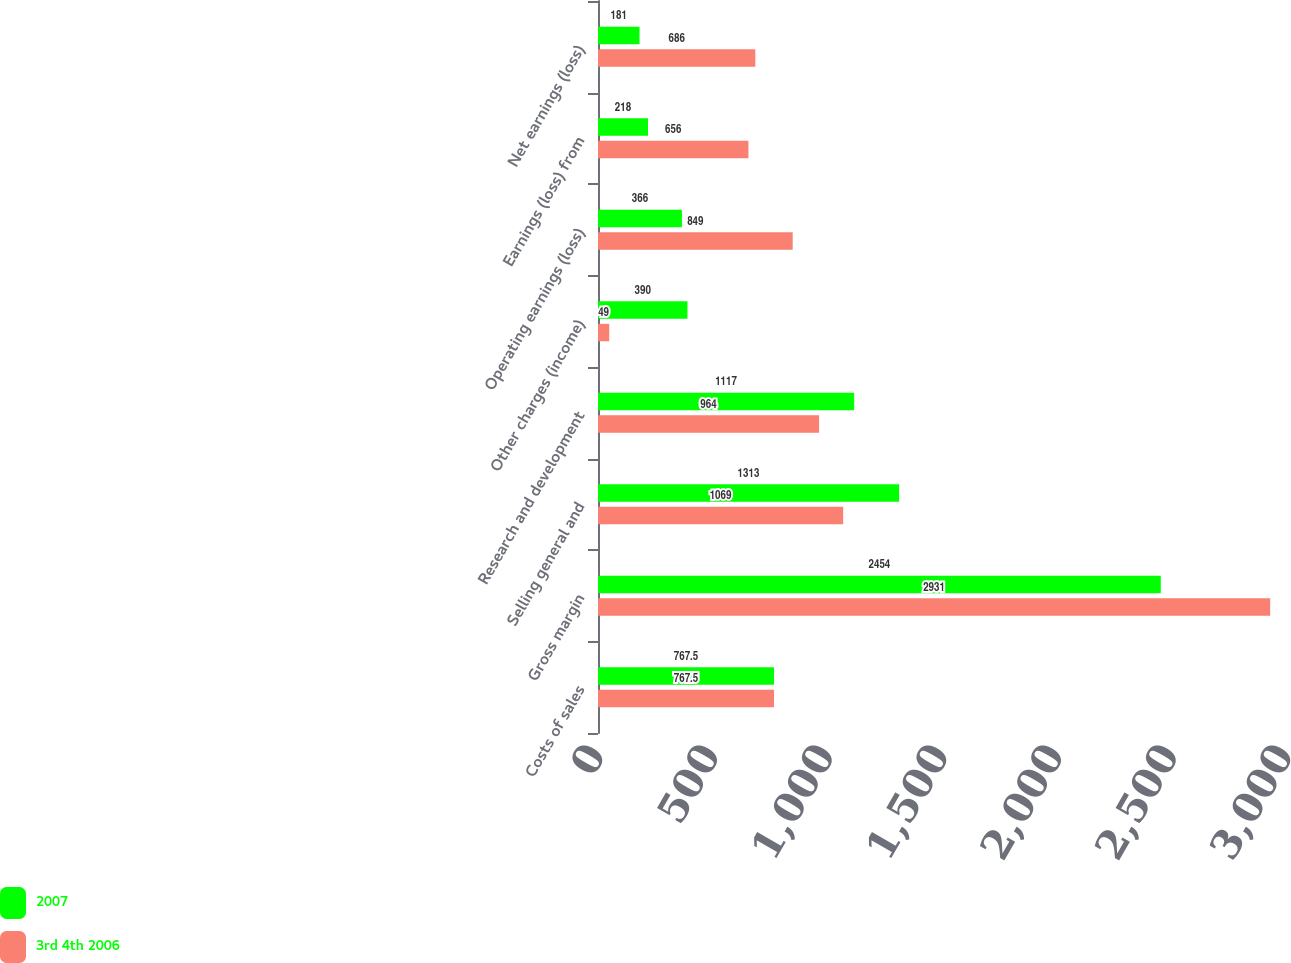<chart> <loc_0><loc_0><loc_500><loc_500><stacked_bar_chart><ecel><fcel>Costs of sales<fcel>Gross margin<fcel>Selling general and<fcel>Research and development<fcel>Other charges (income)<fcel>Operating earnings (loss)<fcel>Earnings (loss) from<fcel>Net earnings (loss)<nl><fcel>2007<fcel>767.5<fcel>2454<fcel>1313<fcel>1117<fcel>390<fcel>366<fcel>218<fcel>181<nl><fcel>3rd 4th 2006<fcel>767.5<fcel>2931<fcel>1069<fcel>964<fcel>49<fcel>849<fcel>656<fcel>686<nl></chart> 